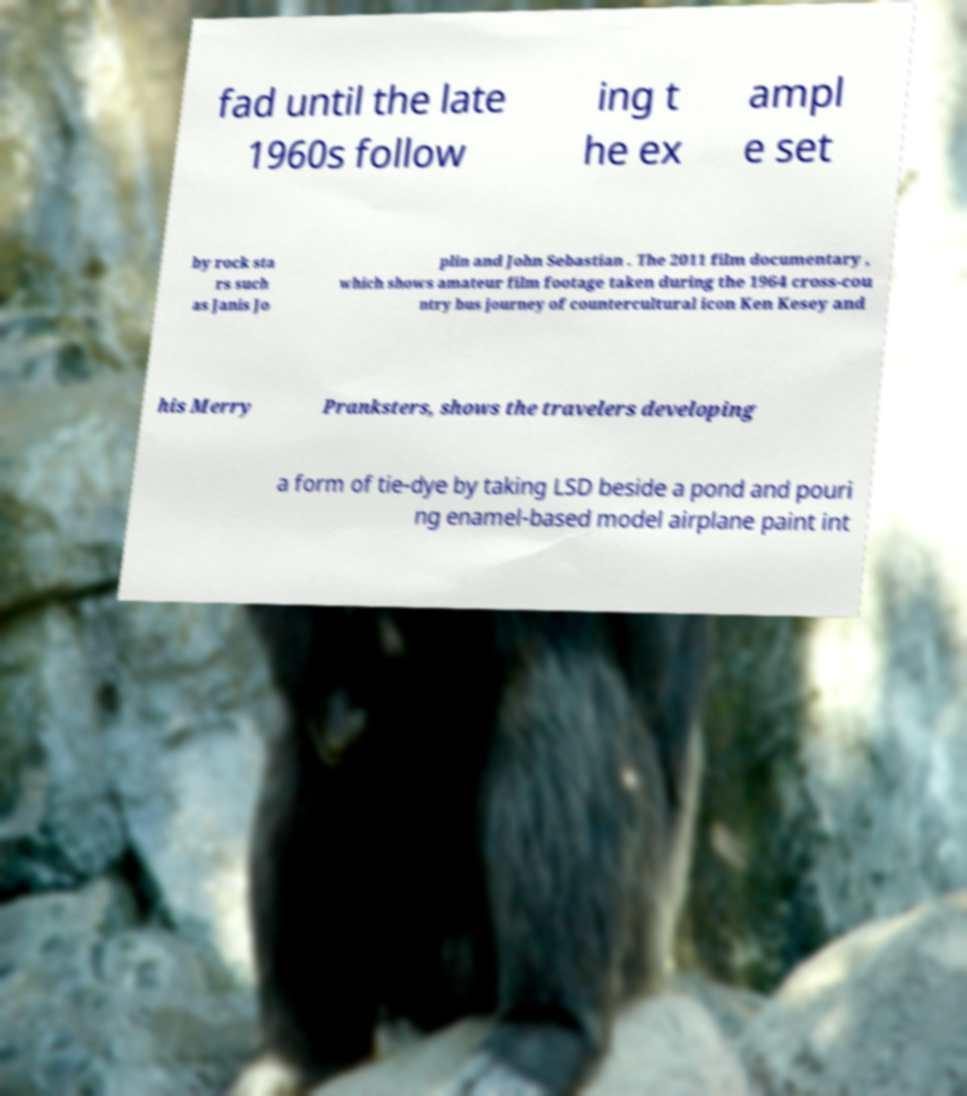Can you accurately transcribe the text from the provided image for me? fad until the late 1960s follow ing t he ex ampl e set by rock sta rs such as Janis Jo plin and John Sebastian . The 2011 film documentary , which shows amateur film footage taken during the 1964 cross-cou ntry bus journey of countercultural icon Ken Kesey and his Merry Pranksters, shows the travelers developing a form of tie-dye by taking LSD beside a pond and pouri ng enamel-based model airplane paint int 